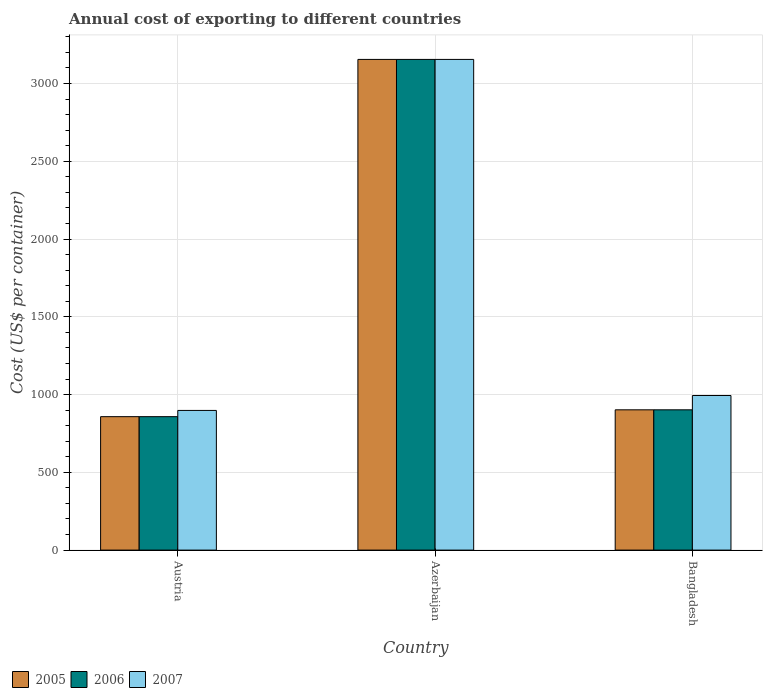How many groups of bars are there?
Your answer should be compact. 3. Are the number of bars per tick equal to the number of legend labels?
Ensure brevity in your answer.  Yes. Are the number of bars on each tick of the X-axis equal?
Offer a terse response. Yes. What is the label of the 2nd group of bars from the left?
Offer a very short reply. Azerbaijan. What is the total annual cost of exporting in 2006 in Azerbaijan?
Your answer should be compact. 3155. Across all countries, what is the maximum total annual cost of exporting in 2006?
Provide a short and direct response. 3155. Across all countries, what is the minimum total annual cost of exporting in 2007?
Your answer should be very brief. 898. In which country was the total annual cost of exporting in 2005 maximum?
Make the answer very short. Azerbaijan. In which country was the total annual cost of exporting in 2006 minimum?
Your response must be concise. Austria. What is the total total annual cost of exporting in 2005 in the graph?
Give a very brief answer. 4915. What is the difference between the total annual cost of exporting in 2007 in Austria and that in Azerbaijan?
Make the answer very short. -2257. What is the difference between the total annual cost of exporting in 2005 in Austria and the total annual cost of exporting in 2006 in Azerbaijan?
Provide a succinct answer. -2297. What is the average total annual cost of exporting in 2007 per country?
Keep it short and to the point. 1682.33. What is the difference between the total annual cost of exporting of/in 2007 and total annual cost of exporting of/in 2006 in Austria?
Give a very brief answer. 40. In how many countries, is the total annual cost of exporting in 2006 greater than 200 US$?
Give a very brief answer. 3. What is the ratio of the total annual cost of exporting in 2005 in Azerbaijan to that in Bangladesh?
Offer a terse response. 3.5. What is the difference between the highest and the second highest total annual cost of exporting in 2005?
Your response must be concise. -2297. What is the difference between the highest and the lowest total annual cost of exporting in 2006?
Make the answer very short. 2297. In how many countries, is the total annual cost of exporting in 2005 greater than the average total annual cost of exporting in 2005 taken over all countries?
Offer a terse response. 1. Is the sum of the total annual cost of exporting in 2007 in Azerbaijan and Bangladesh greater than the maximum total annual cost of exporting in 2006 across all countries?
Offer a terse response. Yes. What does the 3rd bar from the left in Azerbaijan represents?
Ensure brevity in your answer.  2007. What does the 1st bar from the right in Bangladesh represents?
Keep it short and to the point. 2007. How many bars are there?
Provide a succinct answer. 9. How many countries are there in the graph?
Provide a succinct answer. 3. Does the graph contain grids?
Your response must be concise. Yes. How many legend labels are there?
Make the answer very short. 3. What is the title of the graph?
Make the answer very short. Annual cost of exporting to different countries. Does "1980" appear as one of the legend labels in the graph?
Make the answer very short. No. What is the label or title of the Y-axis?
Your answer should be compact. Cost (US$ per container). What is the Cost (US$ per container) in 2005 in Austria?
Your answer should be compact. 858. What is the Cost (US$ per container) of 2006 in Austria?
Make the answer very short. 858. What is the Cost (US$ per container) of 2007 in Austria?
Ensure brevity in your answer.  898. What is the Cost (US$ per container) of 2005 in Azerbaijan?
Provide a short and direct response. 3155. What is the Cost (US$ per container) in 2006 in Azerbaijan?
Make the answer very short. 3155. What is the Cost (US$ per container) in 2007 in Azerbaijan?
Make the answer very short. 3155. What is the Cost (US$ per container) of 2005 in Bangladesh?
Offer a very short reply. 902. What is the Cost (US$ per container) in 2006 in Bangladesh?
Your answer should be very brief. 902. What is the Cost (US$ per container) of 2007 in Bangladesh?
Offer a terse response. 994. Across all countries, what is the maximum Cost (US$ per container) in 2005?
Give a very brief answer. 3155. Across all countries, what is the maximum Cost (US$ per container) of 2006?
Offer a very short reply. 3155. Across all countries, what is the maximum Cost (US$ per container) in 2007?
Give a very brief answer. 3155. Across all countries, what is the minimum Cost (US$ per container) in 2005?
Your response must be concise. 858. Across all countries, what is the minimum Cost (US$ per container) in 2006?
Your response must be concise. 858. Across all countries, what is the minimum Cost (US$ per container) in 2007?
Your answer should be very brief. 898. What is the total Cost (US$ per container) in 2005 in the graph?
Ensure brevity in your answer.  4915. What is the total Cost (US$ per container) in 2006 in the graph?
Your answer should be compact. 4915. What is the total Cost (US$ per container) in 2007 in the graph?
Make the answer very short. 5047. What is the difference between the Cost (US$ per container) of 2005 in Austria and that in Azerbaijan?
Your answer should be very brief. -2297. What is the difference between the Cost (US$ per container) in 2006 in Austria and that in Azerbaijan?
Keep it short and to the point. -2297. What is the difference between the Cost (US$ per container) of 2007 in Austria and that in Azerbaijan?
Your response must be concise. -2257. What is the difference between the Cost (US$ per container) of 2005 in Austria and that in Bangladesh?
Offer a very short reply. -44. What is the difference between the Cost (US$ per container) of 2006 in Austria and that in Bangladesh?
Provide a short and direct response. -44. What is the difference between the Cost (US$ per container) in 2007 in Austria and that in Bangladesh?
Provide a short and direct response. -96. What is the difference between the Cost (US$ per container) of 2005 in Azerbaijan and that in Bangladesh?
Offer a terse response. 2253. What is the difference between the Cost (US$ per container) of 2006 in Azerbaijan and that in Bangladesh?
Provide a succinct answer. 2253. What is the difference between the Cost (US$ per container) in 2007 in Azerbaijan and that in Bangladesh?
Offer a terse response. 2161. What is the difference between the Cost (US$ per container) in 2005 in Austria and the Cost (US$ per container) in 2006 in Azerbaijan?
Provide a succinct answer. -2297. What is the difference between the Cost (US$ per container) of 2005 in Austria and the Cost (US$ per container) of 2007 in Azerbaijan?
Provide a short and direct response. -2297. What is the difference between the Cost (US$ per container) in 2006 in Austria and the Cost (US$ per container) in 2007 in Azerbaijan?
Provide a short and direct response. -2297. What is the difference between the Cost (US$ per container) of 2005 in Austria and the Cost (US$ per container) of 2006 in Bangladesh?
Ensure brevity in your answer.  -44. What is the difference between the Cost (US$ per container) in 2005 in Austria and the Cost (US$ per container) in 2007 in Bangladesh?
Give a very brief answer. -136. What is the difference between the Cost (US$ per container) of 2006 in Austria and the Cost (US$ per container) of 2007 in Bangladesh?
Your answer should be very brief. -136. What is the difference between the Cost (US$ per container) of 2005 in Azerbaijan and the Cost (US$ per container) of 2006 in Bangladesh?
Your response must be concise. 2253. What is the difference between the Cost (US$ per container) of 2005 in Azerbaijan and the Cost (US$ per container) of 2007 in Bangladesh?
Your answer should be compact. 2161. What is the difference between the Cost (US$ per container) of 2006 in Azerbaijan and the Cost (US$ per container) of 2007 in Bangladesh?
Ensure brevity in your answer.  2161. What is the average Cost (US$ per container) of 2005 per country?
Your answer should be very brief. 1638.33. What is the average Cost (US$ per container) in 2006 per country?
Ensure brevity in your answer.  1638.33. What is the average Cost (US$ per container) in 2007 per country?
Offer a terse response. 1682.33. What is the difference between the Cost (US$ per container) of 2005 and Cost (US$ per container) of 2006 in Austria?
Offer a very short reply. 0. What is the difference between the Cost (US$ per container) in 2006 and Cost (US$ per container) in 2007 in Austria?
Keep it short and to the point. -40. What is the difference between the Cost (US$ per container) of 2005 and Cost (US$ per container) of 2006 in Azerbaijan?
Keep it short and to the point. 0. What is the difference between the Cost (US$ per container) of 2005 and Cost (US$ per container) of 2007 in Azerbaijan?
Your answer should be very brief. 0. What is the difference between the Cost (US$ per container) in 2006 and Cost (US$ per container) in 2007 in Azerbaijan?
Keep it short and to the point. 0. What is the difference between the Cost (US$ per container) of 2005 and Cost (US$ per container) of 2007 in Bangladesh?
Make the answer very short. -92. What is the difference between the Cost (US$ per container) of 2006 and Cost (US$ per container) of 2007 in Bangladesh?
Keep it short and to the point. -92. What is the ratio of the Cost (US$ per container) in 2005 in Austria to that in Azerbaijan?
Your answer should be very brief. 0.27. What is the ratio of the Cost (US$ per container) of 2006 in Austria to that in Azerbaijan?
Your response must be concise. 0.27. What is the ratio of the Cost (US$ per container) in 2007 in Austria to that in Azerbaijan?
Your answer should be compact. 0.28. What is the ratio of the Cost (US$ per container) of 2005 in Austria to that in Bangladesh?
Keep it short and to the point. 0.95. What is the ratio of the Cost (US$ per container) of 2006 in Austria to that in Bangladesh?
Your response must be concise. 0.95. What is the ratio of the Cost (US$ per container) in 2007 in Austria to that in Bangladesh?
Give a very brief answer. 0.9. What is the ratio of the Cost (US$ per container) of 2005 in Azerbaijan to that in Bangladesh?
Keep it short and to the point. 3.5. What is the ratio of the Cost (US$ per container) of 2006 in Azerbaijan to that in Bangladesh?
Ensure brevity in your answer.  3.5. What is the ratio of the Cost (US$ per container) of 2007 in Azerbaijan to that in Bangladesh?
Give a very brief answer. 3.17. What is the difference between the highest and the second highest Cost (US$ per container) of 2005?
Your answer should be compact. 2253. What is the difference between the highest and the second highest Cost (US$ per container) of 2006?
Ensure brevity in your answer.  2253. What is the difference between the highest and the second highest Cost (US$ per container) in 2007?
Give a very brief answer. 2161. What is the difference between the highest and the lowest Cost (US$ per container) of 2005?
Your response must be concise. 2297. What is the difference between the highest and the lowest Cost (US$ per container) in 2006?
Keep it short and to the point. 2297. What is the difference between the highest and the lowest Cost (US$ per container) of 2007?
Keep it short and to the point. 2257. 